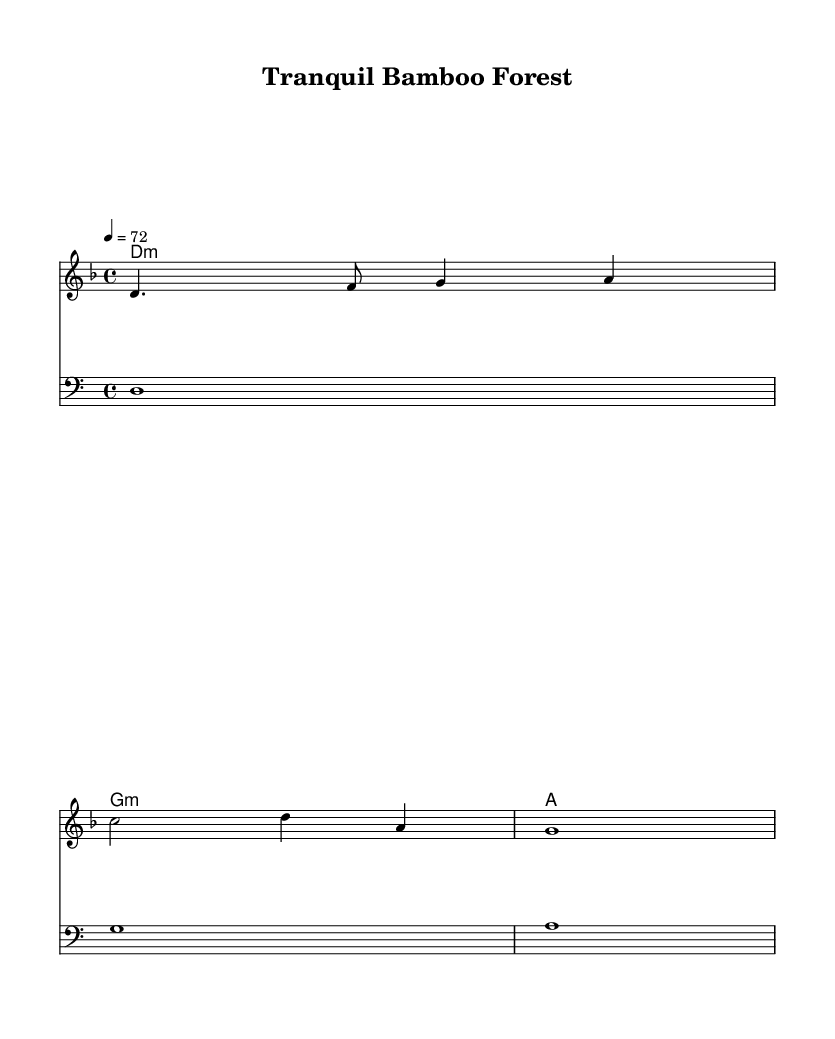What is the key signature of this music? The key signature is indicated by the "d" in "d minor" and there is one flat (B flat) present in the key signature.
Answer: D minor What is the time signature of this piece? The time signature is displayed as "4/4" at the beginning of the score, indicating four beats per measure.
Answer: 4/4 What is the tempo marking of this composition? The tempo marking "4 = 72" shows that the quarter note equals 72 beats per minute, indicating a slow tempo.
Answer: 72 How many measures are in the melody? The melody consists of four measures, as indicated by the music notation and spacing on the staff.
Answer: Four What type of chords are specified in the harmony? The chord symbols "d:m", "g:m", and "a" are utilized, indicating minor and major chords used in this piece.
Answer: Minor and major chords What is the lowest pitch in the bass part? The lowest pitch can be determined from the bass staff and the note "d" is the first note in the bass line.
Answer: D What is the overall mood conveyed by this piece? The piece is titled "Tranquil Bamboo Forest," suggesting a calm and serene atmosphere that aligns with relaxation music.
Answer: Tranquil 